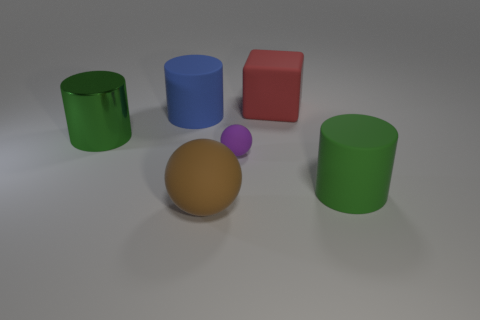Are there more large brown spheres that are to the left of the purple object than yellow metallic cylinders?
Your answer should be compact. Yes. Is the number of large green metallic cylinders that are in front of the big brown thing less than the number of green rubber things?
Offer a terse response. Yes. How many big metallic things have the same color as the big matte ball?
Keep it short and to the point. 0. The big thing that is both on the right side of the large ball and in front of the large metallic cylinder is made of what material?
Provide a short and direct response. Rubber. There is a large rubber cylinder to the left of the brown rubber thing; is its color the same as the matte sphere that is in front of the green rubber cylinder?
Make the answer very short. No. What number of green objects are either small matte balls or spheres?
Your answer should be compact. 0. Are there fewer big green metal things right of the large green matte object than blue cylinders to the right of the big red matte thing?
Keep it short and to the point. No. Is there a red rubber object of the same size as the purple sphere?
Offer a terse response. No. There is a matte thing behind the blue thing; is it the same size as the large blue object?
Keep it short and to the point. Yes. Are there more small matte cubes than big rubber blocks?
Make the answer very short. No. 